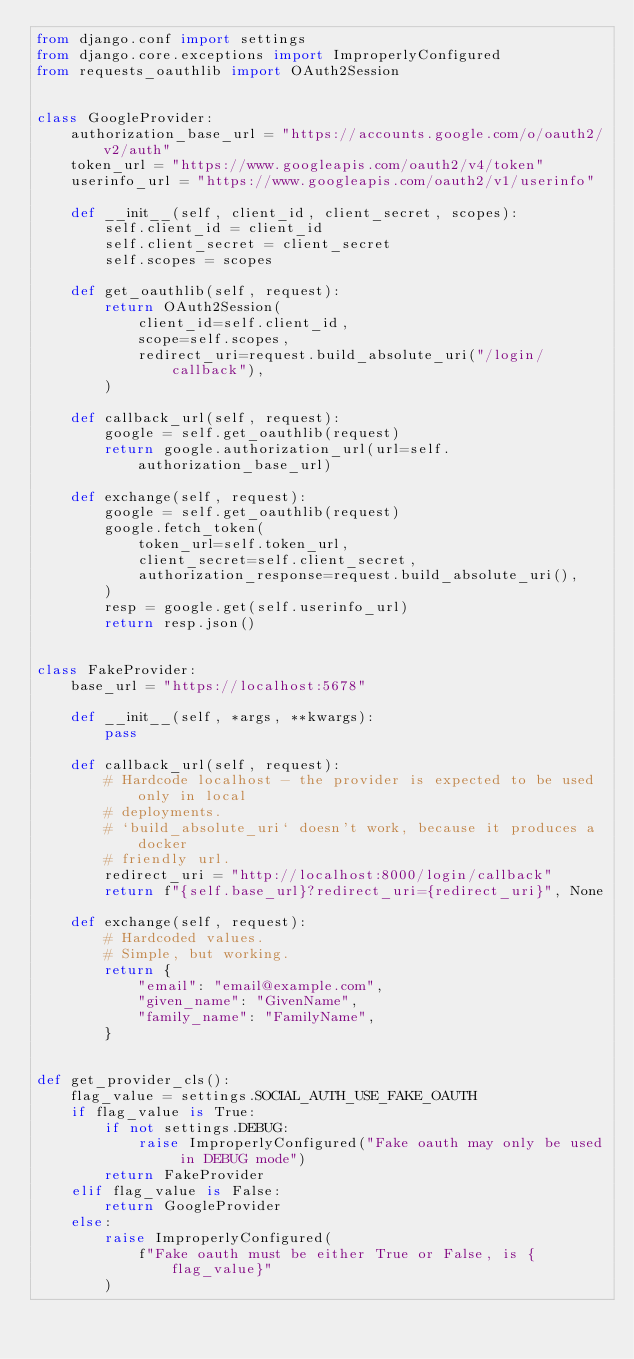Convert code to text. <code><loc_0><loc_0><loc_500><loc_500><_Python_>from django.conf import settings
from django.core.exceptions import ImproperlyConfigured
from requests_oauthlib import OAuth2Session


class GoogleProvider:
    authorization_base_url = "https://accounts.google.com/o/oauth2/v2/auth"
    token_url = "https://www.googleapis.com/oauth2/v4/token"
    userinfo_url = "https://www.googleapis.com/oauth2/v1/userinfo"

    def __init__(self, client_id, client_secret, scopes):
        self.client_id = client_id
        self.client_secret = client_secret
        self.scopes = scopes

    def get_oauthlib(self, request):
        return OAuth2Session(
            client_id=self.client_id,
            scope=self.scopes,
            redirect_uri=request.build_absolute_uri("/login/callback"),
        )

    def callback_url(self, request):
        google = self.get_oauthlib(request)
        return google.authorization_url(url=self.authorization_base_url)

    def exchange(self, request):
        google = self.get_oauthlib(request)
        google.fetch_token(
            token_url=self.token_url,
            client_secret=self.client_secret,
            authorization_response=request.build_absolute_uri(),
        )
        resp = google.get(self.userinfo_url)
        return resp.json()


class FakeProvider:
    base_url = "https://localhost:5678"

    def __init__(self, *args, **kwargs):
        pass

    def callback_url(self, request):
        # Hardcode localhost - the provider is expected to be used only in local
        # deployments.
        # `build_absolute_uri` doesn't work, because it produces a docker
        # friendly url.
        redirect_uri = "http://localhost:8000/login/callback"
        return f"{self.base_url}?redirect_uri={redirect_uri}", None

    def exchange(self, request):
        # Hardcoded values.
        # Simple, but working.
        return {
            "email": "email@example.com",
            "given_name": "GivenName",
            "family_name": "FamilyName",
        }


def get_provider_cls():
    flag_value = settings.SOCIAL_AUTH_USE_FAKE_OAUTH
    if flag_value is True:
        if not settings.DEBUG:
            raise ImproperlyConfigured("Fake oauth may only be used in DEBUG mode")
        return FakeProvider
    elif flag_value is False:
        return GoogleProvider
    else:
        raise ImproperlyConfigured(
            f"Fake oauth must be either True or False, is {flag_value}"
        )
</code> 